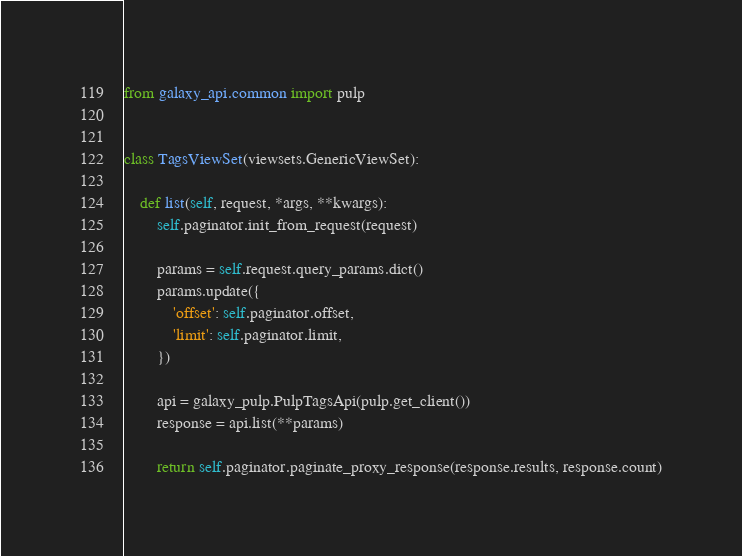<code> <loc_0><loc_0><loc_500><loc_500><_Python_>from galaxy_api.common import pulp


class TagsViewSet(viewsets.GenericViewSet):

    def list(self, request, *args, **kwargs):
        self.paginator.init_from_request(request)

        params = self.request.query_params.dict()
        params.update({
            'offset': self.paginator.offset,
            'limit': self.paginator.limit,
        })

        api = galaxy_pulp.PulpTagsApi(pulp.get_client())
        response = api.list(**params)

        return self.paginator.paginate_proxy_response(response.results, response.count)
</code> 